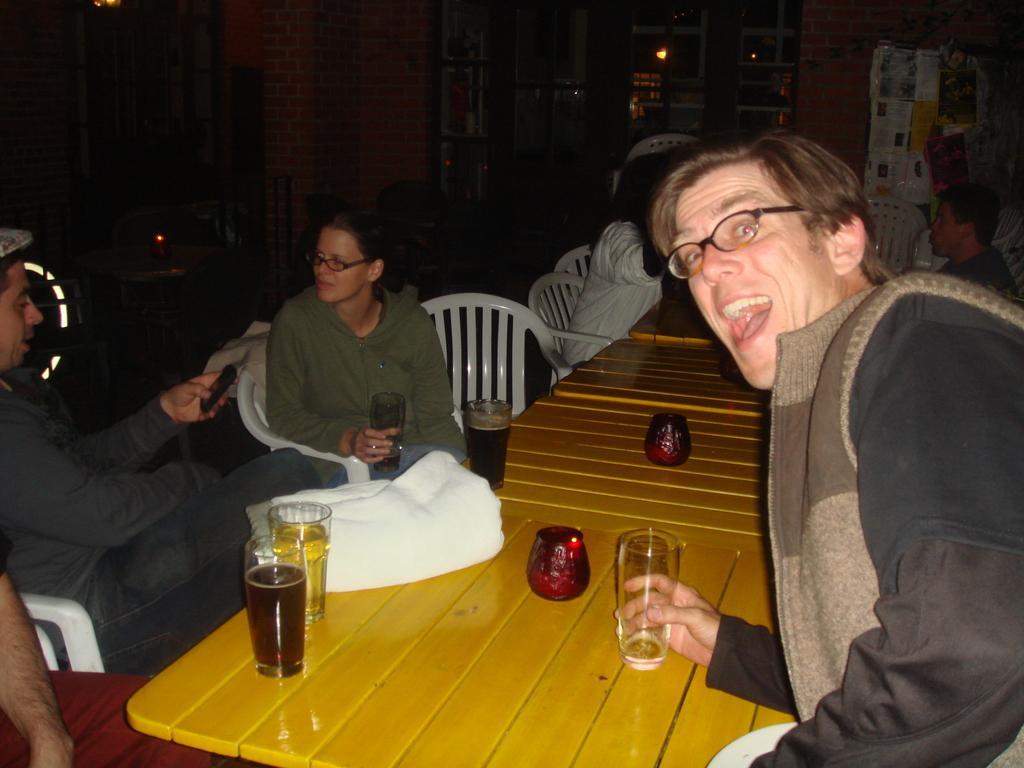In one or two sentences, can you explain what this image depicts? In the image we can see few persons and in the center we can see some persons were sitting. And on the right side we can see one man standing and laughing,which we can see on his face. And coming to the table on table we can see glasses,cloth etc. And coming to the back ground we can see the brick wall and some sign boards. 